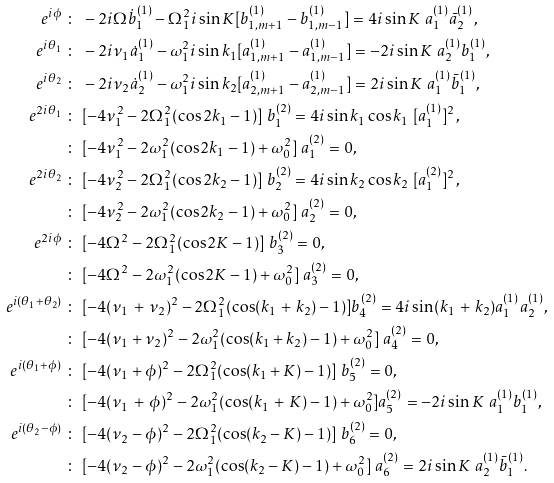Convert formula to latex. <formula><loc_0><loc_0><loc_500><loc_500>e ^ { i \phi } & \ \colon \ - 2 i \Omega \dot { b } _ { 1 } ^ { ( 1 ) } - \Omega _ { 1 } ^ { 2 } i \sin K [ b ^ { ( 1 ) } _ { 1 , m + 1 } - b ^ { ( 1 ) } _ { 1 , m - 1 } ] = 4 i \sin K \ a _ { 1 } ^ { ( 1 ) } \bar { a } _ { 2 } ^ { ( 1 ) } , \\ e ^ { i \theta _ { 1 } } & \ \colon \ - 2 i \nu _ { 1 } \dot { a } _ { 1 } ^ { ( 1 ) } - \omega _ { 1 } ^ { 2 } i \sin k _ { 1 } [ a ^ { ( 1 ) } _ { 1 , m + 1 } - a ^ { ( 1 ) } _ { 1 , m - 1 } ] = - 2 i \sin K \ a _ { 2 } ^ { ( 1 ) } b _ { 1 } ^ { ( 1 ) } , \\ e ^ { i \theta _ { 2 } } & \ \colon \ - 2 i \nu _ { 2 } \dot { a } _ { 2 } ^ { ( 1 ) } - \omega _ { 1 } ^ { 2 } i \sin k _ { 2 } [ a ^ { ( 1 ) } _ { 2 , m + 1 } - a ^ { ( 1 ) } _ { 2 , m - 1 } ] = 2 i \sin K \ a _ { 1 } ^ { ( 1 ) } \bar { b } _ { 1 } ^ { ( 1 ) } , \\ e ^ { 2 i \theta _ { 1 } } & \ \colon \ [ - 4 \nu _ { 1 } ^ { 2 } - 2 \Omega _ { 1 } ^ { 2 } ( \cos 2 k _ { 1 } - 1 ) ] \ b _ { 1 } ^ { ( 2 ) } = 4 i \sin k _ { 1 } \cos k _ { 1 } \ [ a _ { 1 } ^ { ( 1 ) } ] ^ { 2 } , \\ & \ \colon \ [ - 4 \nu _ { 1 } ^ { 2 } - 2 \omega _ { 1 } ^ { 2 } ( \cos 2 k _ { 1 } - 1 ) + \omega _ { 0 } ^ { 2 } ] \ a _ { 1 } ^ { ( 2 ) } = 0 , \\ e ^ { 2 i \theta _ { 2 } } & \ \colon \ [ - 4 \nu _ { 2 } ^ { 2 } - 2 \Omega _ { 1 } ^ { 2 } ( \cos 2 k _ { 2 } - 1 ) ] \ b _ { 2 } ^ { ( 2 ) } = 4 i \sin k _ { 2 } \cos k _ { 2 } \ [ a _ { 1 } ^ { ( 2 ) } ] ^ { 2 } , \\ & \ \colon \ [ - 4 \nu _ { 2 } ^ { 2 } - 2 \omega _ { 1 } ^ { 2 } ( \cos 2 k _ { 2 } - 1 ) + \omega _ { 0 } ^ { 2 } ] \ a _ { 2 } ^ { ( 2 ) } = 0 , \\ e ^ { 2 i \phi } & \ \colon \ [ - 4 \Omega ^ { 2 } - 2 \Omega _ { 1 } ^ { 2 } ( \cos 2 K - 1 ) ] \ b _ { 3 } ^ { ( 2 ) } = 0 , \\ & \ \colon \ [ - 4 \Omega ^ { 2 } - 2 \omega _ { 1 } ^ { 2 } ( \cos 2 K - 1 ) + \omega _ { 0 } ^ { 2 } ] \ a _ { 3 } ^ { ( 2 ) } = 0 , \\ e ^ { i ( \theta _ { 1 } + \theta _ { 2 } ) } & \ \colon \ [ - 4 ( \nu _ { 1 } \, + \, \nu _ { 2 } ) ^ { 2 } - 2 \Omega _ { 1 } ^ { 2 } ( \cos ( k _ { 1 } \, + \, k _ { 2 } ) - 1 ) ] b _ { 4 } ^ { ( 2 ) } = 4 i \sin ( k _ { 1 } \, + \, k _ { 2 } ) a _ { 1 } ^ { ( 1 ) } a _ { 2 } ^ { ( 1 ) } , \\ & \ \colon \ [ - 4 ( \nu _ { 1 } + \nu _ { 2 } ) ^ { 2 } - 2 \omega _ { 1 } ^ { 2 } ( \cos ( k _ { 1 } + k _ { 2 } ) - 1 ) + \omega _ { 0 } ^ { 2 } ] \ a _ { 4 } ^ { ( 2 ) } = 0 , \\ e ^ { i ( \theta _ { 1 } + \phi ) } & \ \colon \ [ - 4 ( \nu _ { 1 } + \phi ) ^ { 2 } - 2 \Omega _ { 1 } ^ { 2 } ( \cos ( k _ { 1 } + K ) - 1 ) ] \ b _ { 5 } ^ { ( 2 ) } = 0 , \\ & \ \colon \ [ - 4 ( \nu _ { 1 } \, + \, \phi ) ^ { 2 } - 2 \omega _ { 1 } ^ { 2 } ( \cos ( k _ { 1 } \, + \, K ) - 1 ) + \omega _ { 0 } ^ { 2 } ] a _ { 5 } ^ { ( 2 ) } = - 2 i \sin K \ a _ { 1 } ^ { ( 1 ) } b _ { 1 } ^ { ( 1 ) } , \\ e ^ { i ( \theta _ { 2 } - \phi ) } & \ \colon \ [ - 4 ( \nu _ { 2 } - \phi ) ^ { 2 } - 2 \Omega _ { 1 } ^ { 2 } ( \cos ( k _ { 2 } - K ) - 1 ) ] \ b _ { 6 } ^ { ( 2 ) } = 0 , \\ & \ \colon \ [ - 4 ( \nu _ { 2 } - \phi ) ^ { 2 } - 2 \omega _ { 1 } ^ { 2 } ( \cos ( k _ { 2 } - K ) - 1 ) + \omega _ { 0 } ^ { 2 } ] \ a _ { 6 } ^ { ( 2 ) } = 2 i \sin K \ a _ { 2 } ^ { ( 1 ) } \bar { b } _ { 1 } ^ { ( 1 ) } .</formula> 